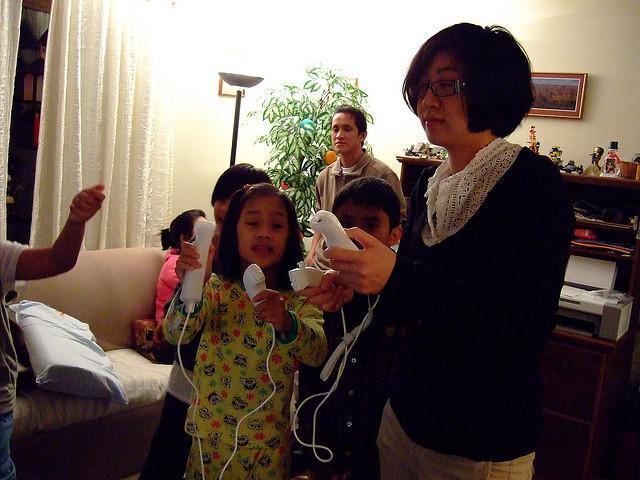How many people are there?
Give a very brief answer. 6. How many couches are there?
Give a very brief answer. 1. 